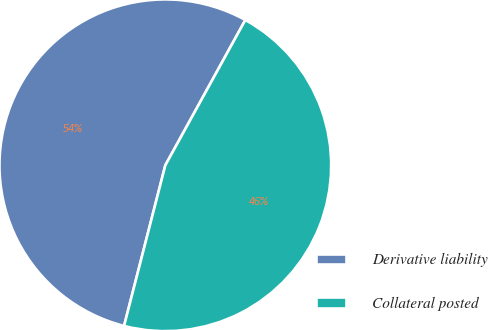Convert chart. <chart><loc_0><loc_0><loc_500><loc_500><pie_chart><fcel>Derivative liability<fcel>Collateral posted<nl><fcel>54.01%<fcel>45.99%<nl></chart> 